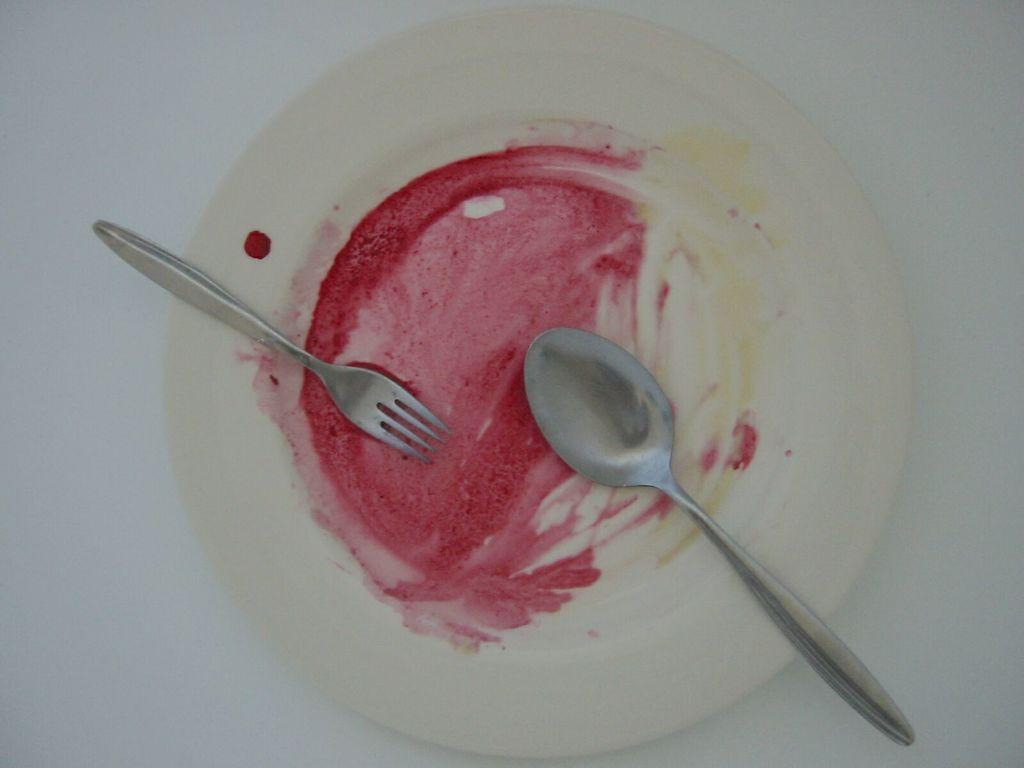What is on the plate that is visible in the image? There is a white plate in the image. What utensils are on the plate? There is a spoon and a fork on the plate. What type of ray is visible on the plate in the image? There is no ray present on the plate in the image. What type of paper is used to wrap the utensils on the plate? There is no paper visible on the plate in the image. 